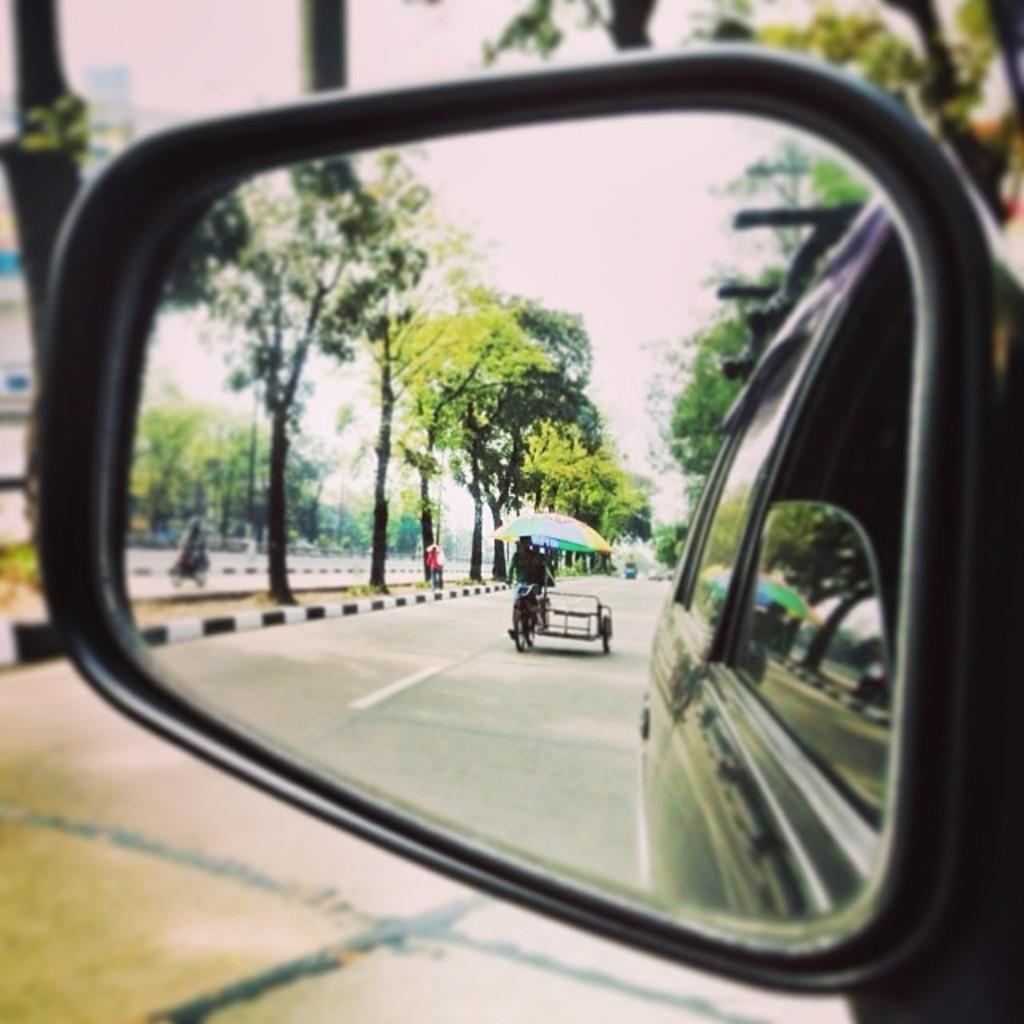How would you summarize this image in a sentence or two? In this picture, we see a black car and we even see a mirror in which the man riding rickshaw is visible. Beside him, the man in the red jacket is walking on the footpath. There are many trees in the background. At the bottom of the picture, we see the road. In the background, it is blurred. 